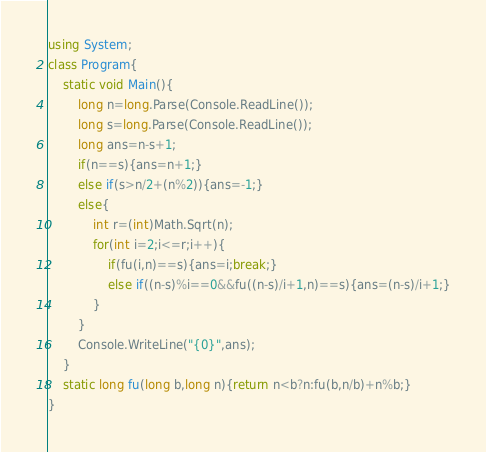<code> <loc_0><loc_0><loc_500><loc_500><_C#_>using System;
class Program{
	static void Main(){
		long n=long.Parse(Console.ReadLine());
		long s=long.Parse(Console.ReadLine());
		long ans=n-s+1;
		if(n==s){ans=n+1;}
		else if(s>n/2+(n%2)){ans=-1;}
		else{
			int r=(int)Math.Sqrt(n);
			for(int i=2;i<=r;i++){
				if(fu(i,n)==s){ans=i;break;}
				else if((n-s)%i==0&&fu((n-s)/i+1,n)==s){ans=(n-s)/i+1;}
			}
		}
		Console.WriteLine("{0}",ans);
	}
	static long fu(long b,long n){return n<b?n:fu(b,n/b)+n%b;}
}</code> 